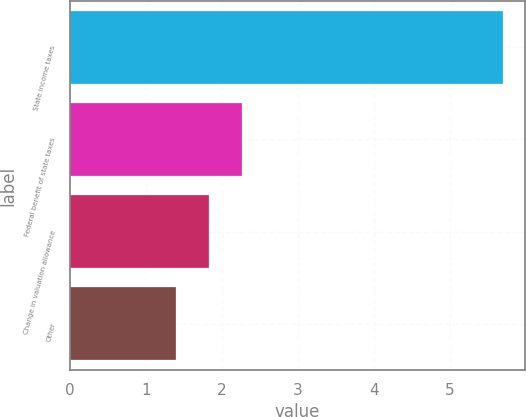Convert chart. <chart><loc_0><loc_0><loc_500><loc_500><bar_chart><fcel>State income taxes<fcel>Federal benefit of state taxes<fcel>Change in valuation allowance<fcel>Other<nl><fcel>5.7<fcel>2.26<fcel>1.83<fcel>1.4<nl></chart> 